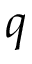Convert formula to latex. <formula><loc_0><loc_0><loc_500><loc_500>q</formula> 